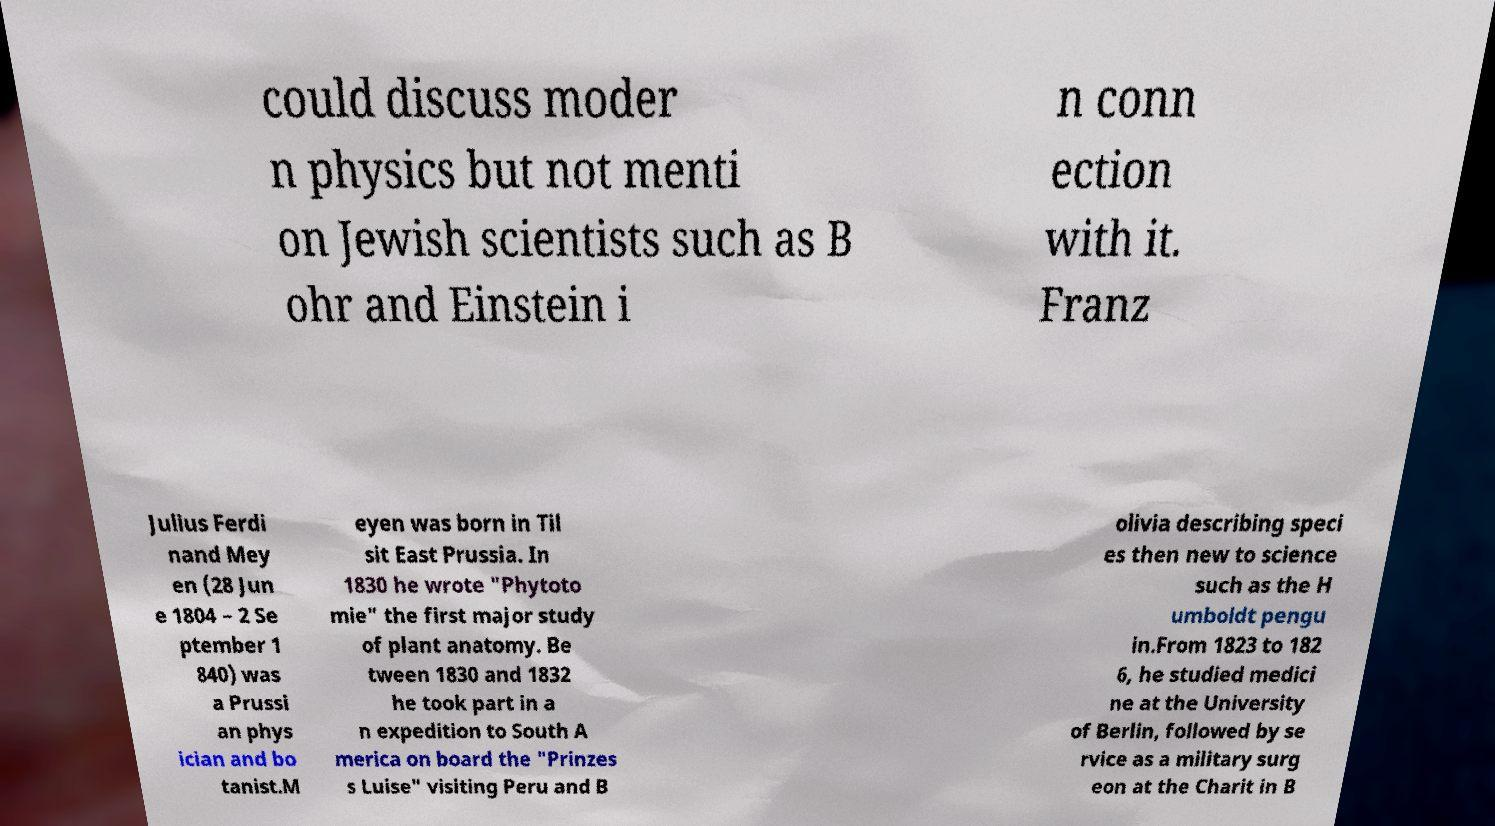Please read and relay the text visible in this image. What does it say? could discuss moder n physics but not menti on Jewish scientists such as B ohr and Einstein i n conn ection with it. Franz Julius Ferdi nand Mey en (28 Jun e 1804 – 2 Se ptember 1 840) was a Prussi an phys ician and bo tanist.M eyen was born in Til sit East Prussia. In 1830 he wrote "Phytoto mie" the first major study of plant anatomy. Be tween 1830 and 1832 he took part in a n expedition to South A merica on board the "Prinzes s Luise" visiting Peru and B olivia describing speci es then new to science such as the H umboldt pengu in.From 1823 to 182 6, he studied medici ne at the University of Berlin, followed by se rvice as a military surg eon at the Charit in B 